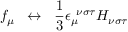<formula> <loc_0><loc_0><loc_500><loc_500>f _ { \mu } \, \leftrightarrow \, \frac { 1 } { 3 } \epsilon _ { \mu } ^ { \, \nu \sigma \tau } H _ { \nu \sigma \tau }</formula> 